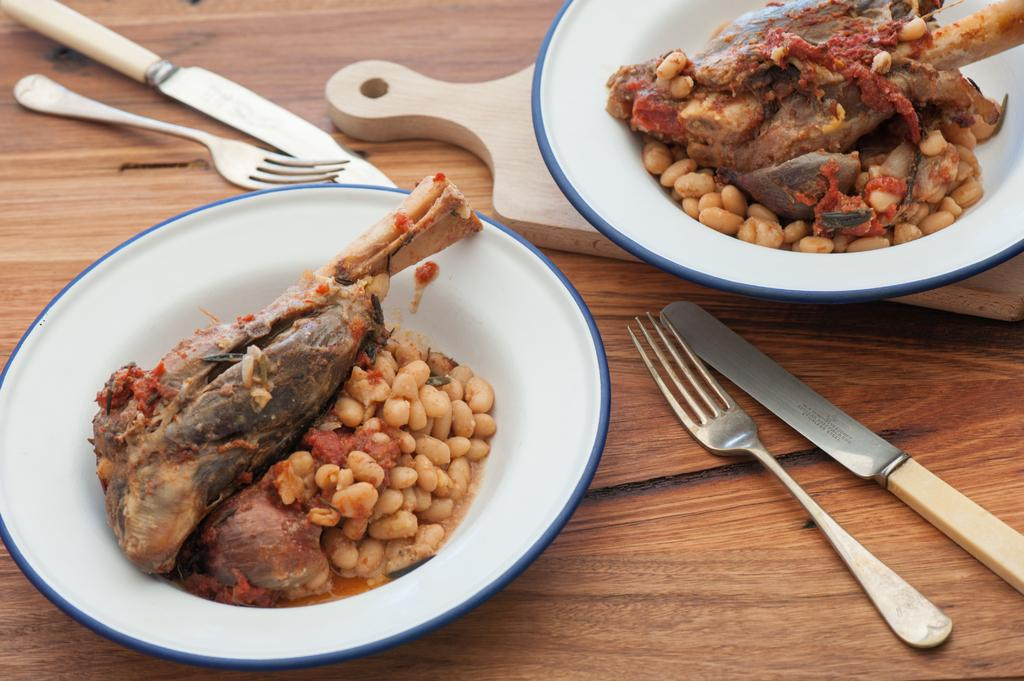What is the main object in the image? There is an object in the image, but its specific nature is not mentioned in the facts. What utensils can be seen in the image? There are forks and knives in the image. What is placed on the wooden surface? There are plates with food items in the image. What is the material of the surface where the objects are placed? The objects are placed on a wooden surface. What type of flower is growing on the wooden surface in the image? There is no flower present in the image; the objects are placed on a wooden surface, but no flowers are mentioned. 